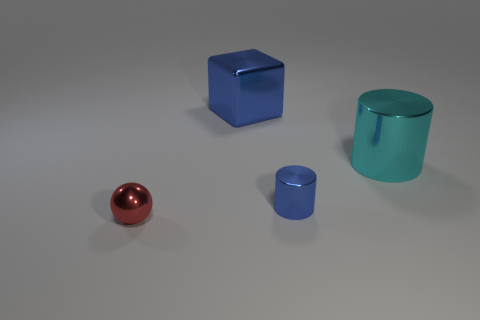What number of tiny cylinders have the same color as the block?
Offer a very short reply. 1. What is the material of the large block that is the same color as the small cylinder?
Provide a short and direct response. Metal. How many objects are metallic objects that are behind the cyan cylinder or tiny brown objects?
Your response must be concise. 1. There is a big shiny object on the right side of the small object to the right of the tiny red shiny thing; what number of shiny cubes are to the left of it?
Your response must be concise. 1. Is there any other thing that has the same size as the cyan metallic cylinder?
Keep it short and to the point. Yes. What shape is the small metal object that is behind the metallic thing in front of the tiny metallic object that is behind the tiny red thing?
Your response must be concise. Cylinder. What number of other objects are the same color as the shiny sphere?
Give a very brief answer. 0. The object in front of the small thing that is on the right side of the big metallic block is what shape?
Your answer should be compact. Sphere. What number of tiny blue shiny cylinders are on the left side of the large cyan cylinder?
Provide a succinct answer. 1. Is there a big cyan thing that has the same material as the big cylinder?
Give a very brief answer. No. 